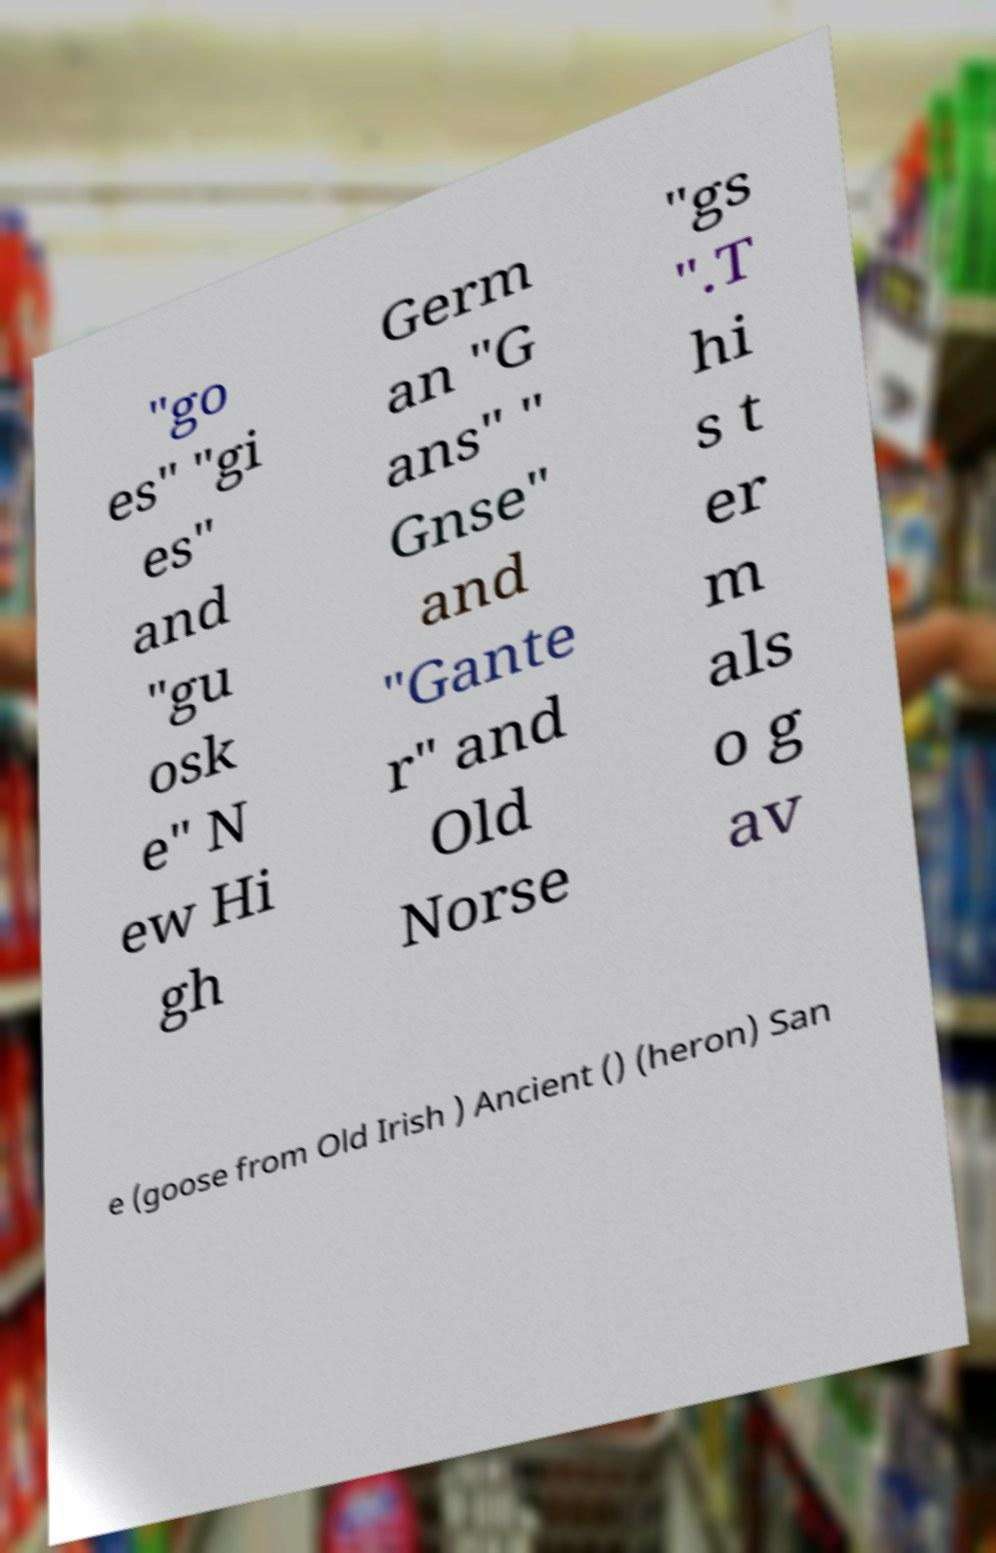Could you assist in decoding the text presented in this image and type it out clearly? "go es" "gi es" and "gu osk e" N ew Hi gh Germ an "G ans" " Gnse" and "Gante r" and Old Norse "gs ".T hi s t er m als o g av e (goose from Old Irish ) Ancient () (heron) San 